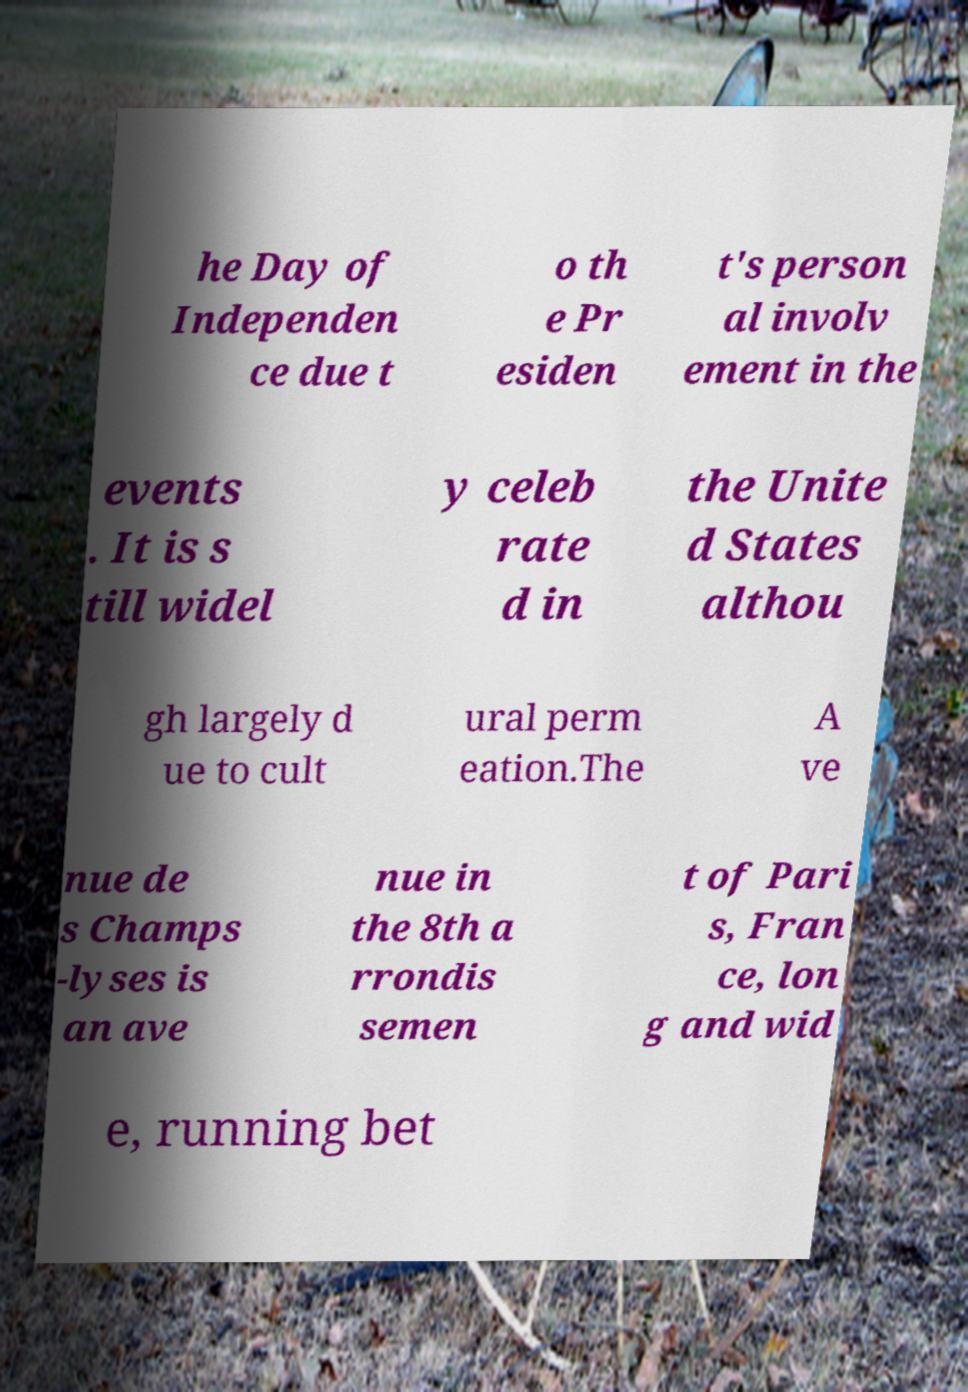I need the written content from this picture converted into text. Can you do that? he Day of Independen ce due t o th e Pr esiden t's person al involv ement in the events . It is s till widel y celeb rate d in the Unite d States althou gh largely d ue to cult ural perm eation.The A ve nue de s Champs -lyses is an ave nue in the 8th a rrondis semen t of Pari s, Fran ce, lon g and wid e, running bet 